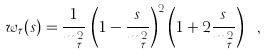<formula> <loc_0><loc_0><loc_500><loc_500>w _ { \tau } ( s ) = { \frac { 1 } { m _ { \tau } ^ { 2 } } } \, \left ( 1 - { \frac { s } { m _ { \tau } ^ { 2 } } } \right ) ^ { 2 } \left ( 1 + 2 { \frac { s } { m _ { \tau } ^ { 2 } } } \right ) \ ,</formula> 